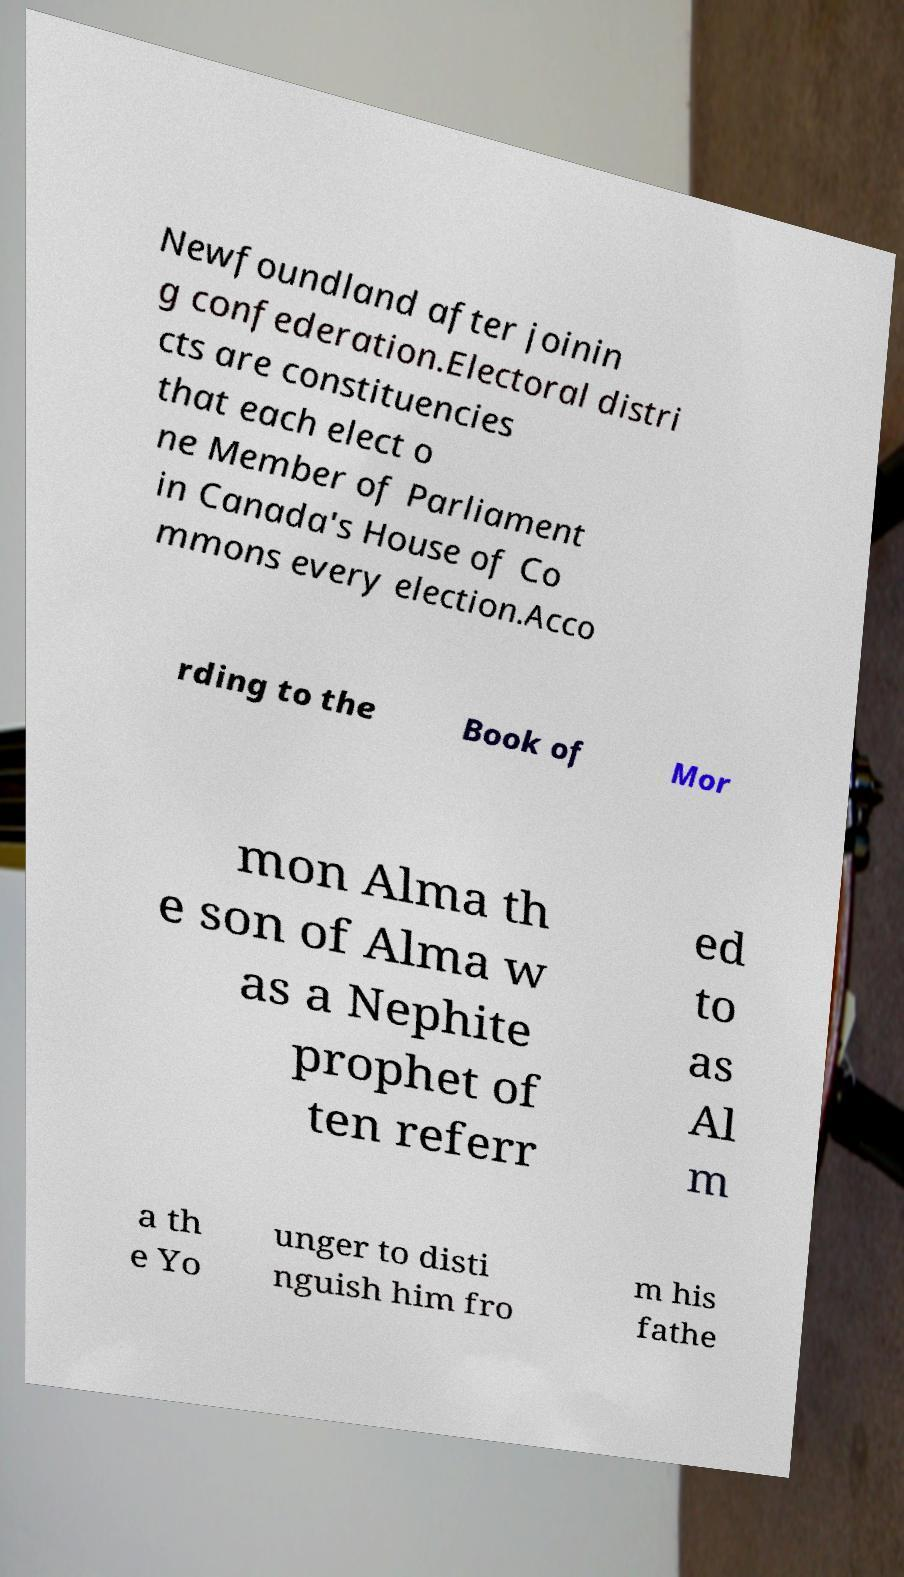Please read and relay the text visible in this image. What does it say? Newfoundland after joinin g confederation.Electoral distri cts are constituencies that each elect o ne Member of Parliament in Canada's House of Co mmons every election.Acco rding to the Book of Mor mon Alma th e son of Alma w as a Nephite prophet of ten referr ed to as Al m a th e Yo unger to disti nguish him fro m his fathe 